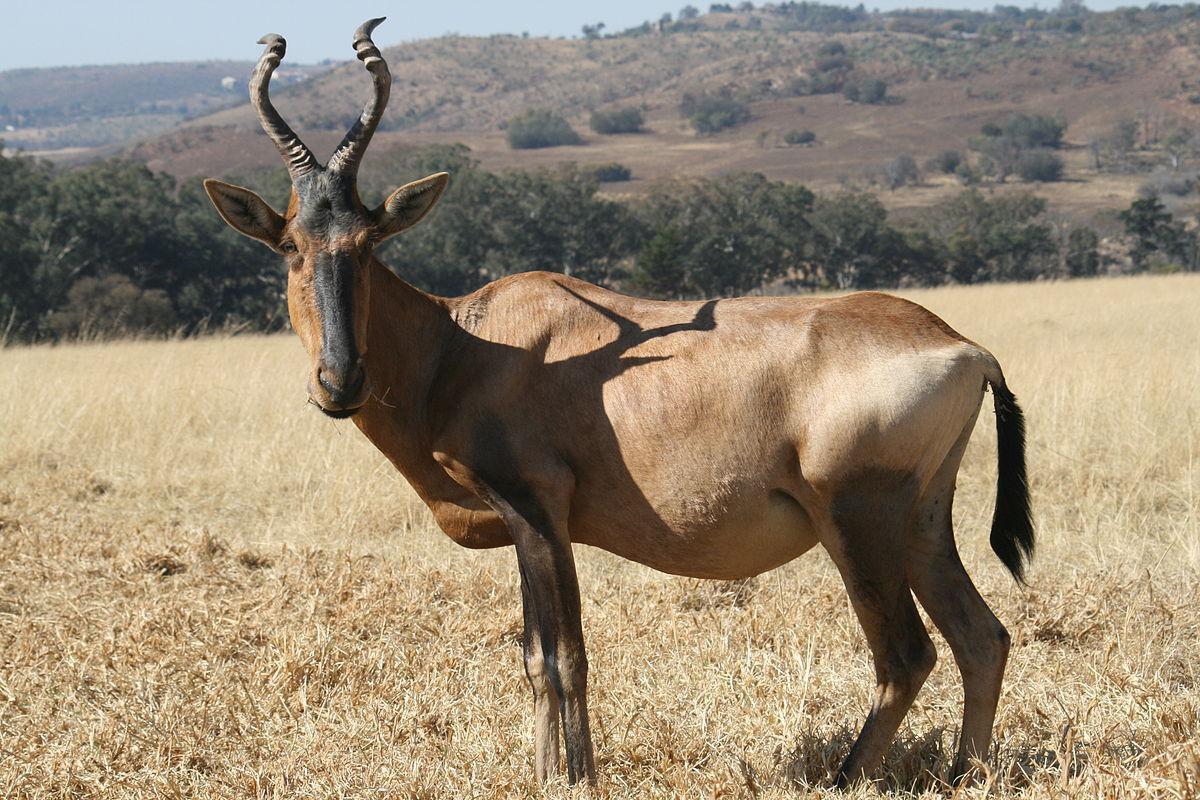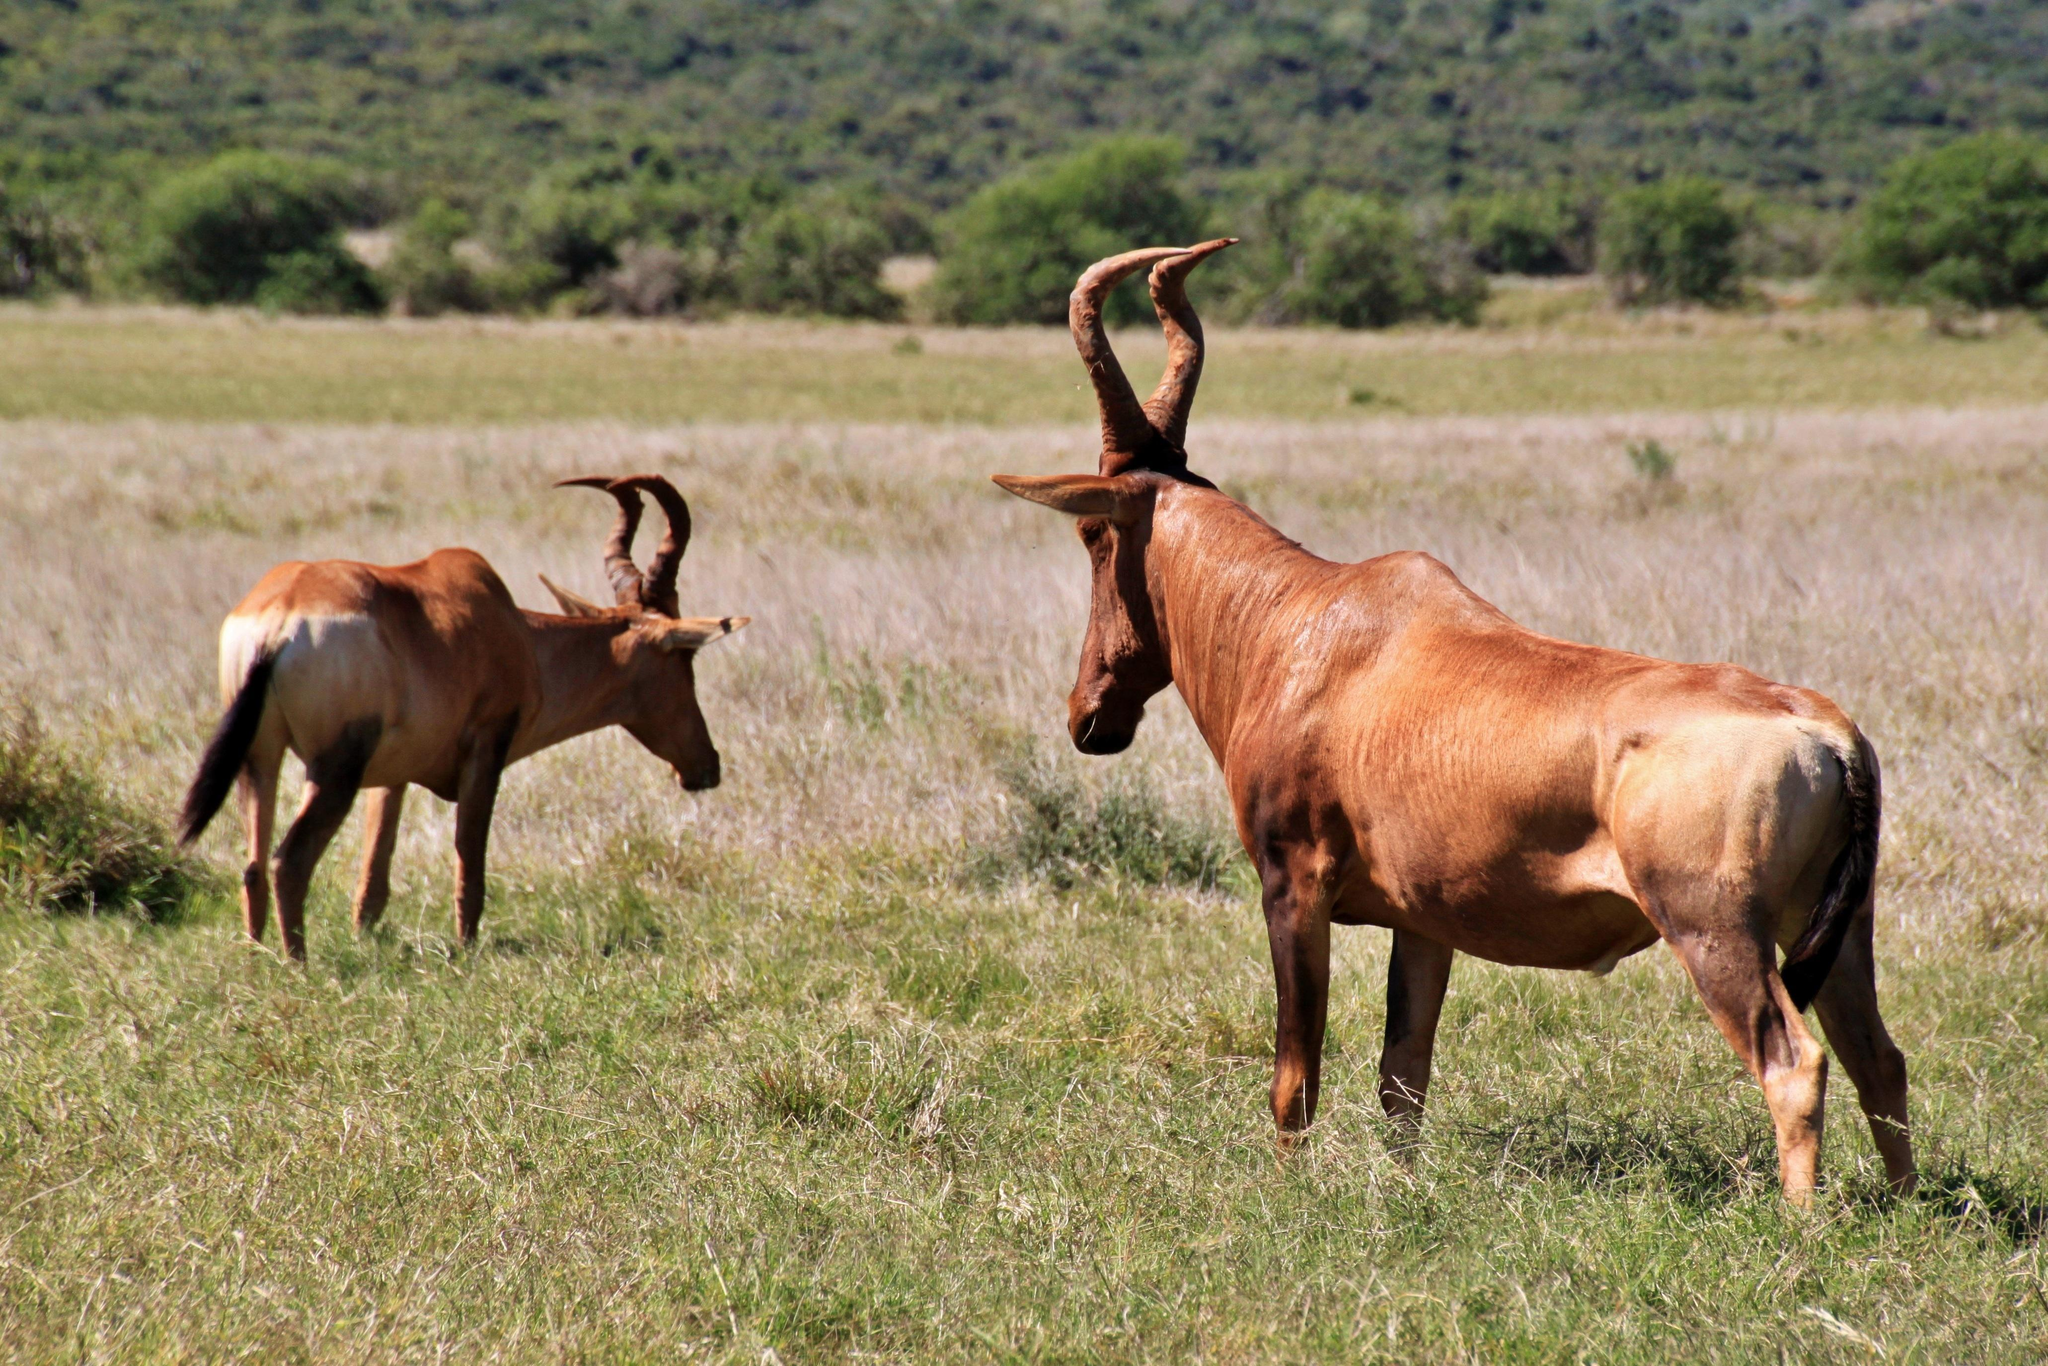The first image is the image on the left, the second image is the image on the right. For the images shown, is this caption "An image shows exactly two antelope that are not sparring." true? Answer yes or no. Yes. 